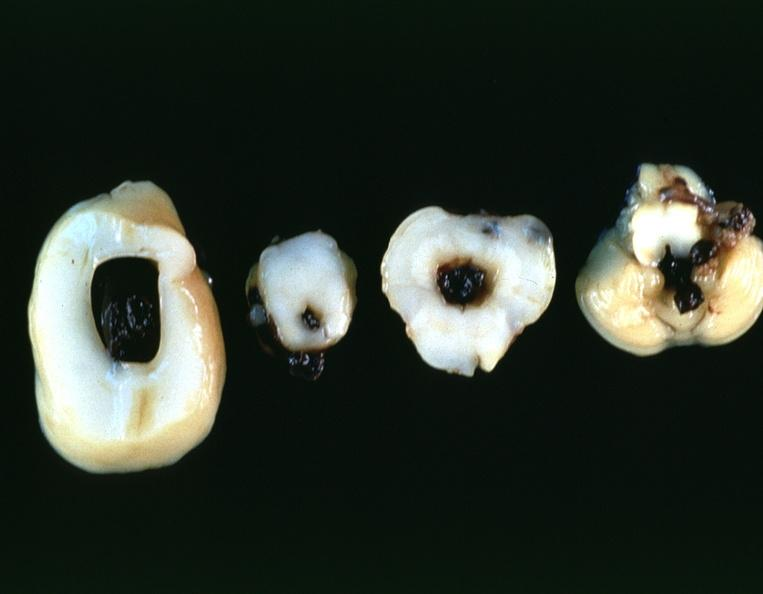s conjoined twins present?
Answer the question using a single word or phrase. No 